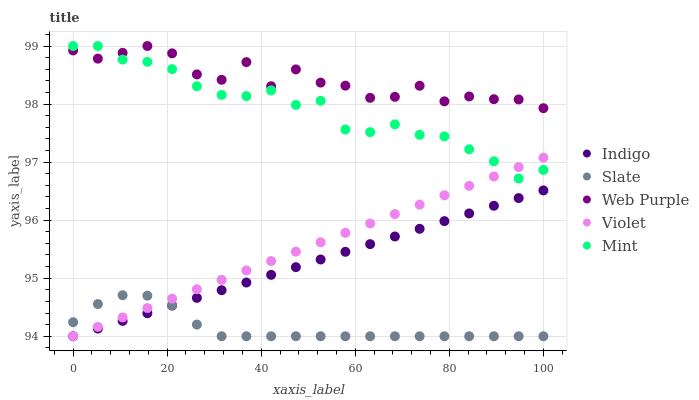Does Slate have the minimum area under the curve?
Answer yes or no. Yes. Does Web Purple have the maximum area under the curve?
Answer yes or no. Yes. Does Indigo have the minimum area under the curve?
Answer yes or no. No. Does Indigo have the maximum area under the curve?
Answer yes or no. No. Is Violet the smoothest?
Answer yes or no. Yes. Is Web Purple the roughest?
Answer yes or no. Yes. Is Slate the smoothest?
Answer yes or no. No. Is Slate the roughest?
Answer yes or no. No. Does Slate have the lowest value?
Answer yes or no. Yes. Does Web Purple have the lowest value?
Answer yes or no. No. Does Web Purple have the highest value?
Answer yes or no. Yes. Does Indigo have the highest value?
Answer yes or no. No. Is Slate less than Mint?
Answer yes or no. Yes. Is Mint greater than Slate?
Answer yes or no. Yes. Does Violet intersect Indigo?
Answer yes or no. Yes. Is Violet less than Indigo?
Answer yes or no. No. Is Violet greater than Indigo?
Answer yes or no. No. Does Slate intersect Mint?
Answer yes or no. No. 